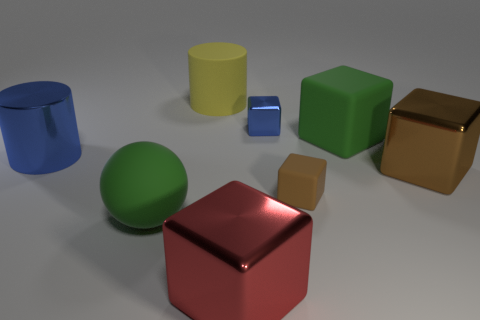There is a metal cube that is the same color as the large metal cylinder; what is its size?
Give a very brief answer. Small. What number of other things are the same size as the brown rubber block?
Provide a succinct answer. 1. Does the small thing behind the green rubber block have the same material as the big brown thing?
Make the answer very short. Yes. How many other objects are the same color as the rubber cylinder?
Provide a succinct answer. 0. What number of other things are there of the same shape as the red thing?
Your answer should be compact. 4. There is a blue metal object right of the large blue metal cylinder; is it the same shape as the brown thing on the left side of the brown metal block?
Ensure brevity in your answer.  Yes. Is the number of brown blocks that are to the left of the large red cube the same as the number of yellow matte things that are in front of the big green matte sphere?
Your response must be concise. Yes. What is the shape of the green rubber thing that is behind the large metallic block that is to the right of the large green rubber thing behind the tiny rubber object?
Your answer should be very brief. Cube. Is the large cylinder to the left of the large yellow object made of the same material as the block in front of the big rubber ball?
Make the answer very short. Yes. What shape is the small brown object that is on the left side of the large brown block?
Provide a short and direct response. Cube. 